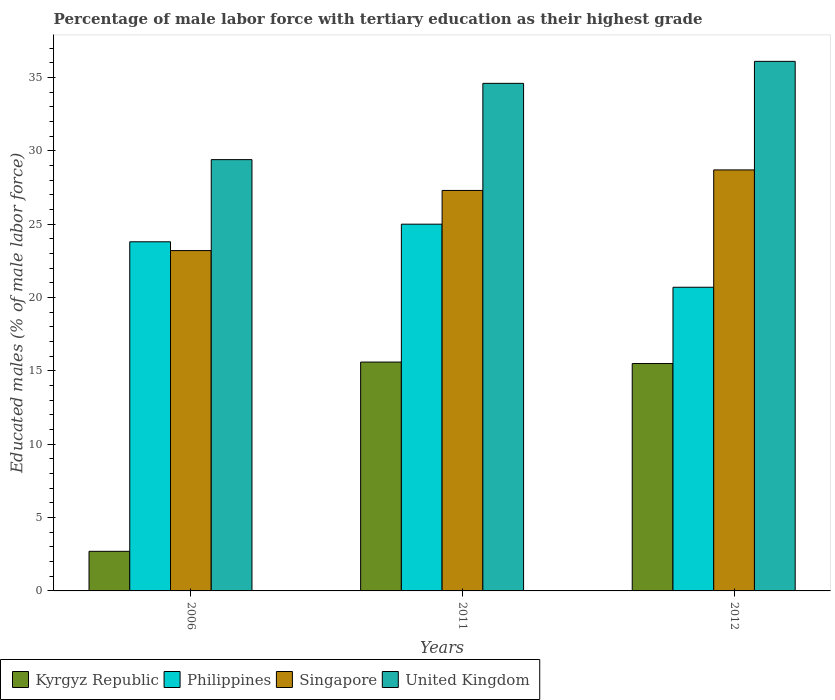How many groups of bars are there?
Make the answer very short. 3. Are the number of bars per tick equal to the number of legend labels?
Your answer should be very brief. Yes. How many bars are there on the 2nd tick from the right?
Your response must be concise. 4. What is the percentage of male labor force with tertiary education in Singapore in 2011?
Make the answer very short. 27.3. Across all years, what is the minimum percentage of male labor force with tertiary education in Singapore?
Keep it short and to the point. 23.2. In which year was the percentage of male labor force with tertiary education in Singapore maximum?
Give a very brief answer. 2012. In which year was the percentage of male labor force with tertiary education in Philippines minimum?
Make the answer very short. 2012. What is the total percentage of male labor force with tertiary education in United Kingdom in the graph?
Ensure brevity in your answer.  100.1. What is the difference between the percentage of male labor force with tertiary education in Philippines in 2006 and that in 2012?
Keep it short and to the point. 3.1. What is the difference between the percentage of male labor force with tertiary education in Philippines in 2011 and the percentage of male labor force with tertiary education in Kyrgyz Republic in 2012?
Ensure brevity in your answer.  9.5. What is the average percentage of male labor force with tertiary education in Philippines per year?
Your answer should be compact. 23.17. In the year 2012, what is the difference between the percentage of male labor force with tertiary education in United Kingdom and percentage of male labor force with tertiary education in Singapore?
Make the answer very short. 7.4. In how many years, is the percentage of male labor force with tertiary education in Singapore greater than 1 %?
Your answer should be compact. 3. What is the ratio of the percentage of male labor force with tertiary education in United Kingdom in 2011 to that in 2012?
Offer a terse response. 0.96. Is the percentage of male labor force with tertiary education in Singapore in 2006 less than that in 2011?
Your answer should be compact. Yes. Is the difference between the percentage of male labor force with tertiary education in United Kingdom in 2006 and 2012 greater than the difference between the percentage of male labor force with tertiary education in Singapore in 2006 and 2012?
Your response must be concise. No. What is the difference between the highest and the lowest percentage of male labor force with tertiary education in Philippines?
Your answer should be very brief. 4.3. In how many years, is the percentage of male labor force with tertiary education in Philippines greater than the average percentage of male labor force with tertiary education in Philippines taken over all years?
Give a very brief answer. 2. Is the sum of the percentage of male labor force with tertiary education in Philippines in 2011 and 2012 greater than the maximum percentage of male labor force with tertiary education in United Kingdom across all years?
Ensure brevity in your answer.  Yes. What does the 1st bar from the right in 2006 represents?
Make the answer very short. United Kingdom. Is it the case that in every year, the sum of the percentage of male labor force with tertiary education in Singapore and percentage of male labor force with tertiary education in Philippines is greater than the percentage of male labor force with tertiary education in United Kingdom?
Ensure brevity in your answer.  Yes. How many years are there in the graph?
Your answer should be compact. 3. What is the difference between two consecutive major ticks on the Y-axis?
Provide a succinct answer. 5. Does the graph contain grids?
Your response must be concise. No. What is the title of the graph?
Provide a succinct answer. Percentage of male labor force with tertiary education as their highest grade. Does "Burkina Faso" appear as one of the legend labels in the graph?
Keep it short and to the point. No. What is the label or title of the X-axis?
Offer a terse response. Years. What is the label or title of the Y-axis?
Your answer should be very brief. Educated males (% of male labor force). What is the Educated males (% of male labor force) of Kyrgyz Republic in 2006?
Provide a succinct answer. 2.7. What is the Educated males (% of male labor force) of Philippines in 2006?
Your response must be concise. 23.8. What is the Educated males (% of male labor force) in Singapore in 2006?
Your answer should be very brief. 23.2. What is the Educated males (% of male labor force) of United Kingdom in 2006?
Your response must be concise. 29.4. What is the Educated males (% of male labor force) in Kyrgyz Republic in 2011?
Give a very brief answer. 15.6. What is the Educated males (% of male labor force) in Philippines in 2011?
Your answer should be compact. 25. What is the Educated males (% of male labor force) in Singapore in 2011?
Offer a terse response. 27.3. What is the Educated males (% of male labor force) of United Kingdom in 2011?
Provide a succinct answer. 34.6. What is the Educated males (% of male labor force) of Philippines in 2012?
Provide a succinct answer. 20.7. What is the Educated males (% of male labor force) in Singapore in 2012?
Ensure brevity in your answer.  28.7. What is the Educated males (% of male labor force) in United Kingdom in 2012?
Offer a very short reply. 36.1. Across all years, what is the maximum Educated males (% of male labor force) of Kyrgyz Republic?
Provide a succinct answer. 15.6. Across all years, what is the maximum Educated males (% of male labor force) in Singapore?
Give a very brief answer. 28.7. Across all years, what is the maximum Educated males (% of male labor force) of United Kingdom?
Give a very brief answer. 36.1. Across all years, what is the minimum Educated males (% of male labor force) of Kyrgyz Republic?
Make the answer very short. 2.7. Across all years, what is the minimum Educated males (% of male labor force) of Philippines?
Ensure brevity in your answer.  20.7. Across all years, what is the minimum Educated males (% of male labor force) in Singapore?
Give a very brief answer. 23.2. Across all years, what is the minimum Educated males (% of male labor force) of United Kingdom?
Your answer should be very brief. 29.4. What is the total Educated males (% of male labor force) of Kyrgyz Republic in the graph?
Offer a very short reply. 33.8. What is the total Educated males (% of male labor force) of Philippines in the graph?
Keep it short and to the point. 69.5. What is the total Educated males (% of male labor force) in Singapore in the graph?
Your answer should be compact. 79.2. What is the total Educated males (% of male labor force) of United Kingdom in the graph?
Provide a short and direct response. 100.1. What is the difference between the Educated males (% of male labor force) in Kyrgyz Republic in 2006 and that in 2011?
Your answer should be very brief. -12.9. What is the difference between the Educated males (% of male labor force) of Philippines in 2006 and that in 2011?
Your answer should be very brief. -1.2. What is the difference between the Educated males (% of male labor force) in United Kingdom in 2006 and that in 2011?
Give a very brief answer. -5.2. What is the difference between the Educated males (% of male labor force) in Singapore in 2006 and that in 2012?
Your response must be concise. -5.5. What is the difference between the Educated males (% of male labor force) in Singapore in 2011 and that in 2012?
Your answer should be very brief. -1.4. What is the difference between the Educated males (% of male labor force) in Kyrgyz Republic in 2006 and the Educated males (% of male labor force) in Philippines in 2011?
Provide a succinct answer. -22.3. What is the difference between the Educated males (% of male labor force) of Kyrgyz Republic in 2006 and the Educated males (% of male labor force) of Singapore in 2011?
Provide a succinct answer. -24.6. What is the difference between the Educated males (% of male labor force) in Kyrgyz Republic in 2006 and the Educated males (% of male labor force) in United Kingdom in 2011?
Give a very brief answer. -31.9. What is the difference between the Educated males (% of male labor force) of Philippines in 2006 and the Educated males (% of male labor force) of Singapore in 2011?
Offer a very short reply. -3.5. What is the difference between the Educated males (% of male labor force) of Kyrgyz Republic in 2006 and the Educated males (% of male labor force) of Philippines in 2012?
Offer a terse response. -18. What is the difference between the Educated males (% of male labor force) of Kyrgyz Republic in 2006 and the Educated males (% of male labor force) of United Kingdom in 2012?
Ensure brevity in your answer.  -33.4. What is the difference between the Educated males (% of male labor force) of Philippines in 2006 and the Educated males (% of male labor force) of United Kingdom in 2012?
Your response must be concise. -12.3. What is the difference between the Educated males (% of male labor force) of Kyrgyz Republic in 2011 and the Educated males (% of male labor force) of Singapore in 2012?
Your answer should be very brief. -13.1. What is the difference between the Educated males (% of male labor force) in Kyrgyz Republic in 2011 and the Educated males (% of male labor force) in United Kingdom in 2012?
Offer a terse response. -20.5. What is the difference between the Educated males (% of male labor force) of Philippines in 2011 and the Educated males (% of male labor force) of United Kingdom in 2012?
Your answer should be very brief. -11.1. What is the difference between the Educated males (% of male labor force) in Singapore in 2011 and the Educated males (% of male labor force) in United Kingdom in 2012?
Your answer should be compact. -8.8. What is the average Educated males (% of male labor force) of Kyrgyz Republic per year?
Ensure brevity in your answer.  11.27. What is the average Educated males (% of male labor force) in Philippines per year?
Your answer should be compact. 23.17. What is the average Educated males (% of male labor force) of Singapore per year?
Offer a terse response. 26.4. What is the average Educated males (% of male labor force) of United Kingdom per year?
Provide a short and direct response. 33.37. In the year 2006, what is the difference between the Educated males (% of male labor force) in Kyrgyz Republic and Educated males (% of male labor force) in Philippines?
Your response must be concise. -21.1. In the year 2006, what is the difference between the Educated males (% of male labor force) of Kyrgyz Republic and Educated males (% of male labor force) of Singapore?
Make the answer very short. -20.5. In the year 2006, what is the difference between the Educated males (% of male labor force) of Kyrgyz Republic and Educated males (% of male labor force) of United Kingdom?
Ensure brevity in your answer.  -26.7. In the year 2006, what is the difference between the Educated males (% of male labor force) of Philippines and Educated males (% of male labor force) of United Kingdom?
Provide a short and direct response. -5.6. In the year 2011, what is the difference between the Educated males (% of male labor force) of Kyrgyz Republic and Educated males (% of male labor force) of Philippines?
Provide a succinct answer. -9.4. In the year 2011, what is the difference between the Educated males (% of male labor force) of Philippines and Educated males (% of male labor force) of Singapore?
Offer a very short reply. -2.3. In the year 2012, what is the difference between the Educated males (% of male labor force) of Kyrgyz Republic and Educated males (% of male labor force) of Singapore?
Offer a terse response. -13.2. In the year 2012, what is the difference between the Educated males (% of male labor force) of Kyrgyz Republic and Educated males (% of male labor force) of United Kingdom?
Keep it short and to the point. -20.6. In the year 2012, what is the difference between the Educated males (% of male labor force) of Philippines and Educated males (% of male labor force) of United Kingdom?
Provide a short and direct response. -15.4. In the year 2012, what is the difference between the Educated males (% of male labor force) of Singapore and Educated males (% of male labor force) of United Kingdom?
Offer a very short reply. -7.4. What is the ratio of the Educated males (% of male labor force) of Kyrgyz Republic in 2006 to that in 2011?
Keep it short and to the point. 0.17. What is the ratio of the Educated males (% of male labor force) in Philippines in 2006 to that in 2011?
Offer a terse response. 0.95. What is the ratio of the Educated males (% of male labor force) of Singapore in 2006 to that in 2011?
Your answer should be compact. 0.85. What is the ratio of the Educated males (% of male labor force) of United Kingdom in 2006 to that in 2011?
Give a very brief answer. 0.85. What is the ratio of the Educated males (% of male labor force) of Kyrgyz Republic in 2006 to that in 2012?
Provide a short and direct response. 0.17. What is the ratio of the Educated males (% of male labor force) of Philippines in 2006 to that in 2012?
Provide a short and direct response. 1.15. What is the ratio of the Educated males (% of male labor force) of Singapore in 2006 to that in 2012?
Give a very brief answer. 0.81. What is the ratio of the Educated males (% of male labor force) of United Kingdom in 2006 to that in 2012?
Your answer should be very brief. 0.81. What is the ratio of the Educated males (% of male labor force) in Kyrgyz Republic in 2011 to that in 2012?
Your answer should be very brief. 1.01. What is the ratio of the Educated males (% of male labor force) in Philippines in 2011 to that in 2012?
Your answer should be very brief. 1.21. What is the ratio of the Educated males (% of male labor force) of Singapore in 2011 to that in 2012?
Your answer should be compact. 0.95. What is the ratio of the Educated males (% of male labor force) of United Kingdom in 2011 to that in 2012?
Keep it short and to the point. 0.96. What is the difference between the highest and the second highest Educated males (% of male labor force) in United Kingdom?
Provide a short and direct response. 1.5. What is the difference between the highest and the lowest Educated males (% of male labor force) in Singapore?
Offer a very short reply. 5.5. What is the difference between the highest and the lowest Educated males (% of male labor force) of United Kingdom?
Offer a very short reply. 6.7. 